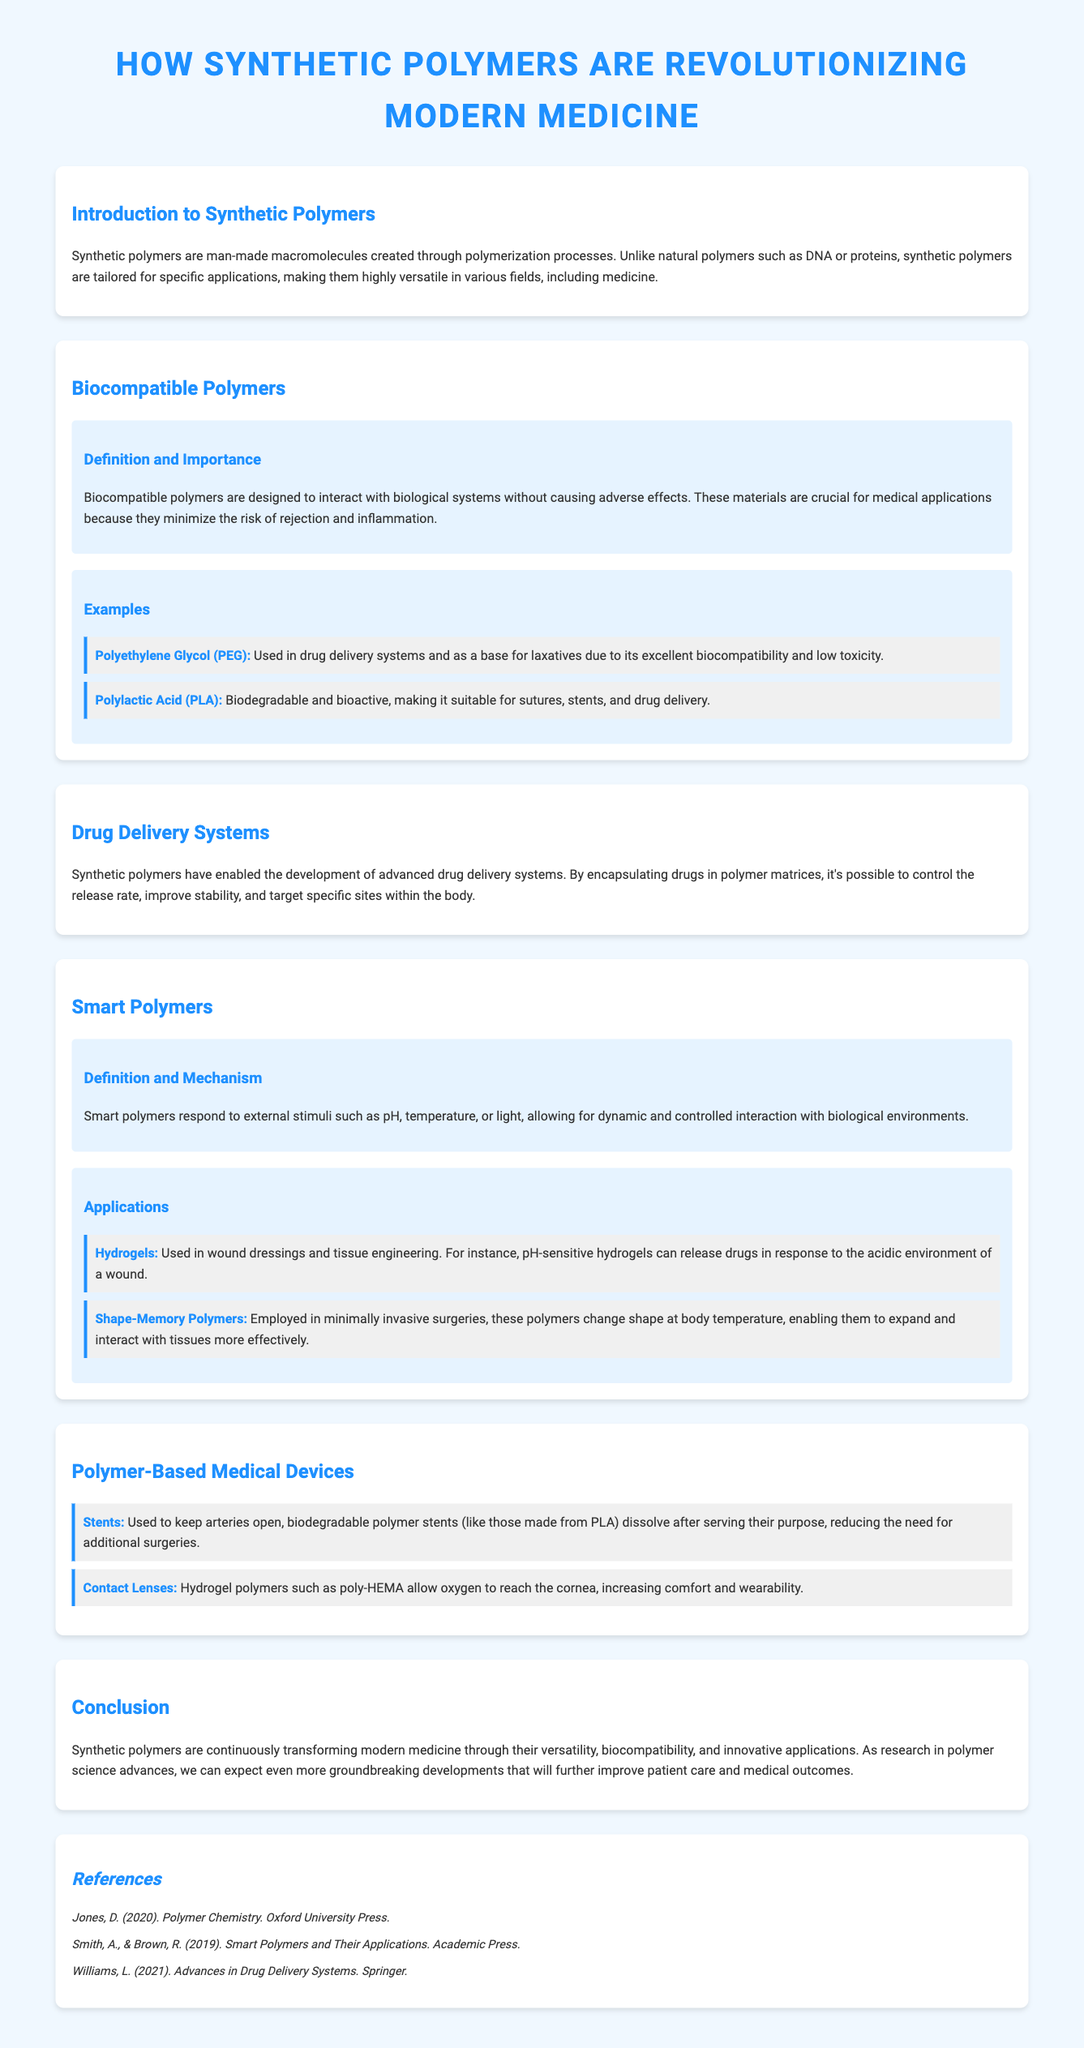What are synthetic polymers? Synthetic polymers are man-made macromolecules created through polymerization processes.
Answer: Man-made macromolecules What is the function of biocompatible polymers? Biocompatible polymers are designed to interact with biological systems without causing adverse effects.
Answer: Minimize rejection and inflammation What is an example of a smart polymer used in wound dressings? pH-sensitive hydrogels can release drugs in response to the acidic environment of a wound.
Answer: Hydrogels How do biodegradable polymer stents function? Biodegradable polymer stents dissolve after serving their purpose, reducing the need for additional surgeries.
Answer: They dissolve What is Polyethylene Glycol (PEG) used for? PEG is used in drug delivery systems and as a base for laxatives due to its excellent biocompatibility and low toxicity.
Answer: Drug delivery systems What is the significance of smart polymers in surgery? Smart polymers change shape at body temperature, enabling them to expand and interact with tissues more effectively.
Answer: Expand and interact with tissues What type of polymer is used in contact lenses for oxygen permeability? Hydrogel polymers such as poly-HEMA allow oxygen to reach the cornea, increasing comfort and wearability.
Answer: Hydrogel How are synthetic polymers transforming modern medicine? Synthetic polymers are continuously transforming modern medicine through their versatility, biocompatibility, and innovative applications.
Answer: Versatility and biocompatibility 